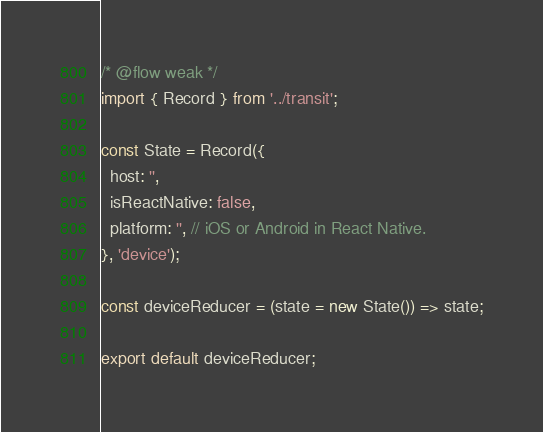<code> <loc_0><loc_0><loc_500><loc_500><_JavaScript_>/* @flow weak */
import { Record } from '../transit';

const State = Record({
  host: '',
  isReactNative: false,
  platform: '', // iOS or Android in React Native.
}, 'device');

const deviceReducer = (state = new State()) => state;

export default deviceReducer;
</code> 